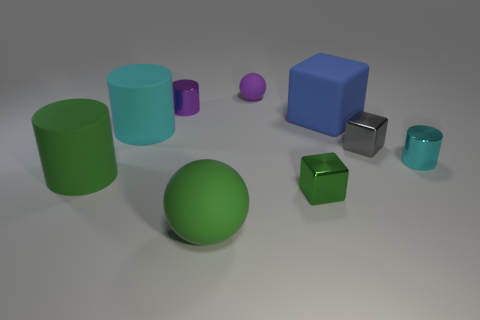Subtract 1 cylinders. How many cylinders are left? 3 Subtract all gray cylinders. Subtract all purple cubes. How many cylinders are left? 4 Add 1 gray shiny things. How many objects exist? 10 Subtract all cylinders. How many objects are left? 5 Subtract all green spheres. Subtract all tiny cyan metallic objects. How many objects are left? 7 Add 2 green metallic things. How many green metallic things are left? 3 Add 4 big balls. How many big balls exist? 5 Subtract 0 purple cubes. How many objects are left? 9 